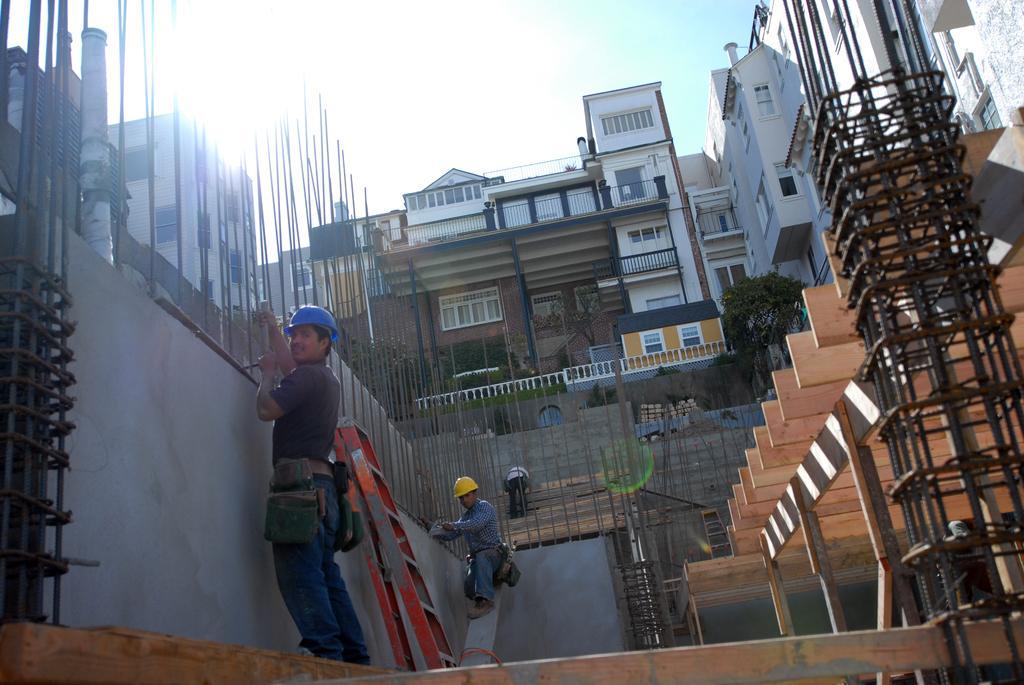Please provide a concise description of this image. At the bottom of the image few people are standing and holding something in their hands. Behind them there are some trees and plants and buildings. At the top of the image there are some clouds and sky. 